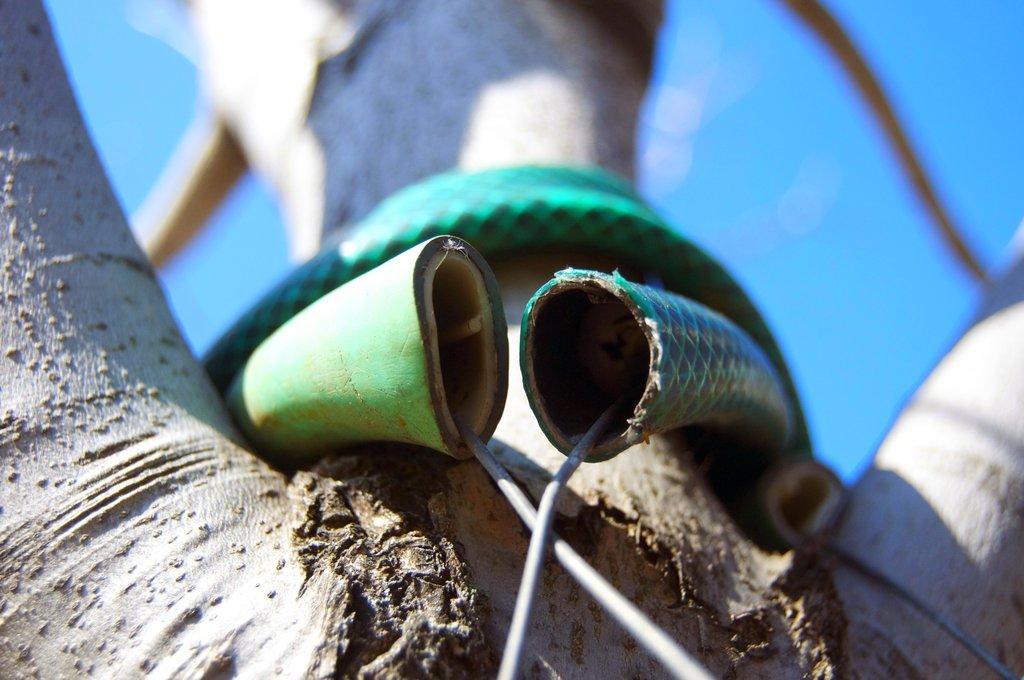Can you describe this image briefly? In this image there is one tree and to that tree there is one pipe and some wires are there in that pipe, in the background there is sky. 